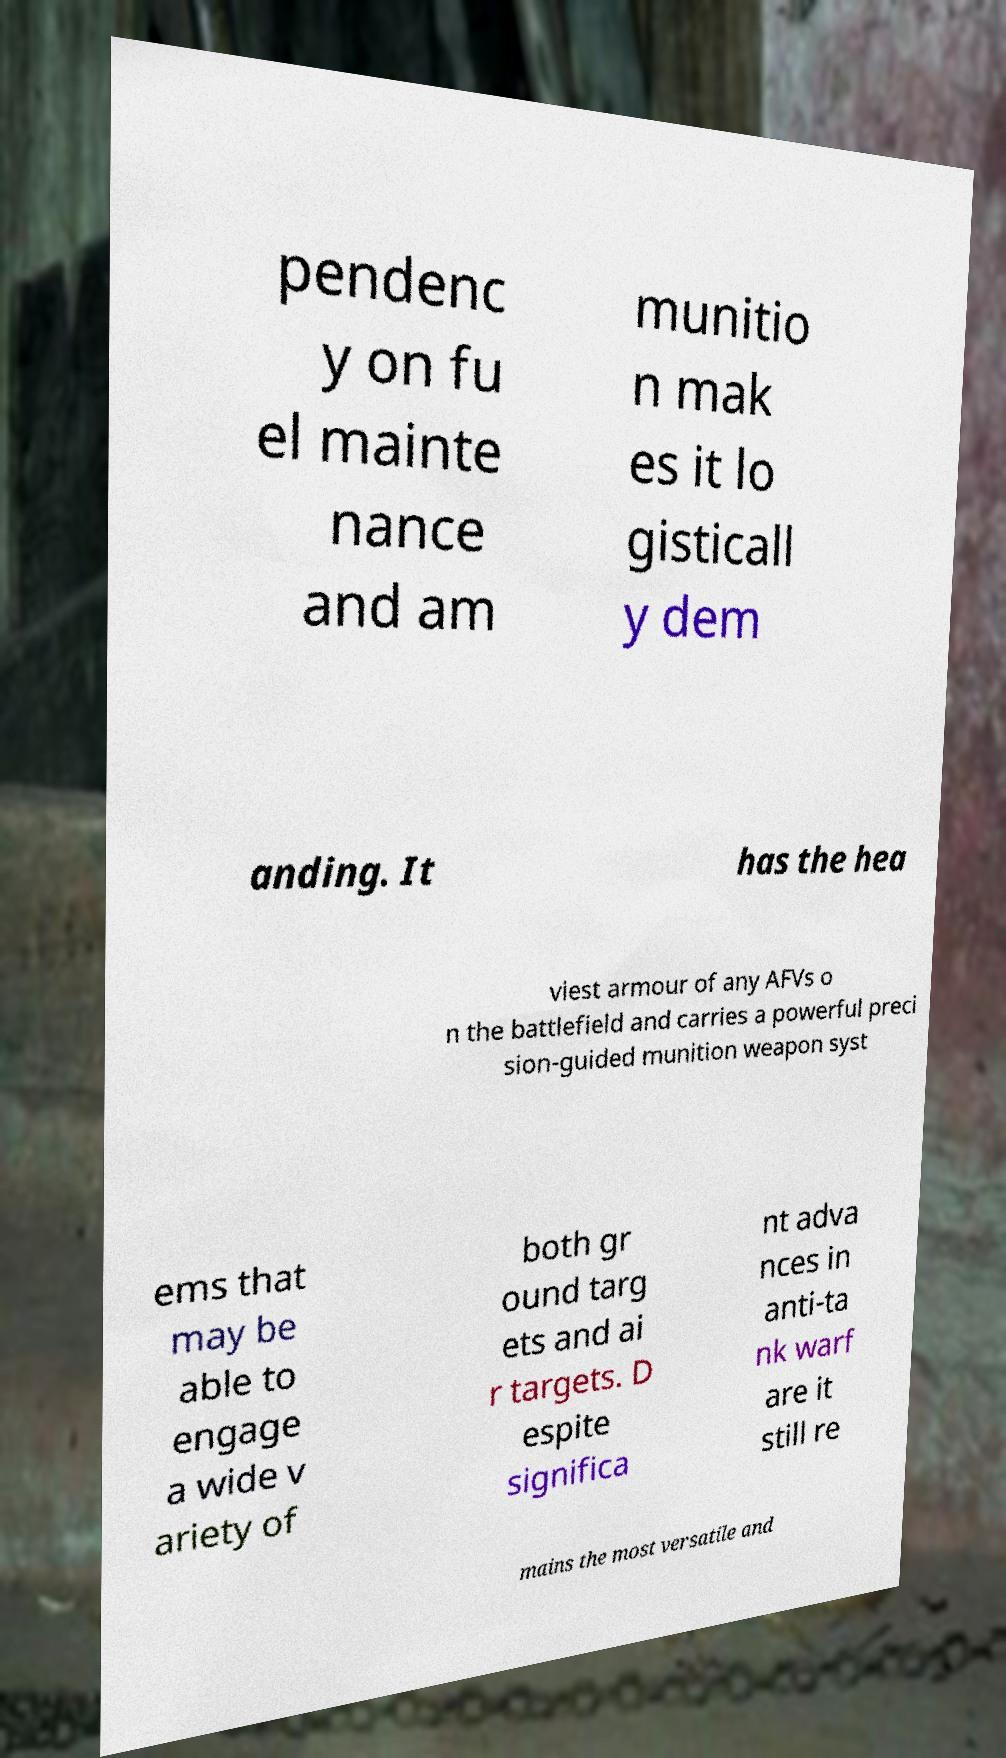Can you read and provide the text displayed in the image?This photo seems to have some interesting text. Can you extract and type it out for me? pendenc y on fu el mainte nance and am munitio n mak es it lo gisticall y dem anding. It has the hea viest armour of any AFVs o n the battlefield and carries a powerful preci sion-guided munition weapon syst ems that may be able to engage a wide v ariety of both gr ound targ ets and ai r targets. D espite significa nt adva nces in anti-ta nk warf are it still re mains the most versatile and 